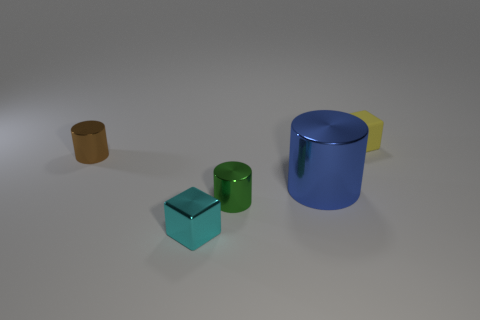Add 3 yellow blocks. How many objects exist? 8 Subtract all small cylinders. How many cylinders are left? 1 Subtract all cylinders. How many objects are left? 2 Add 2 big yellow cylinders. How many big yellow cylinders exist? 2 Subtract 0 gray blocks. How many objects are left? 5 Subtract all large cylinders. Subtract all tiny cyan things. How many objects are left? 3 Add 4 green things. How many green things are left? 5 